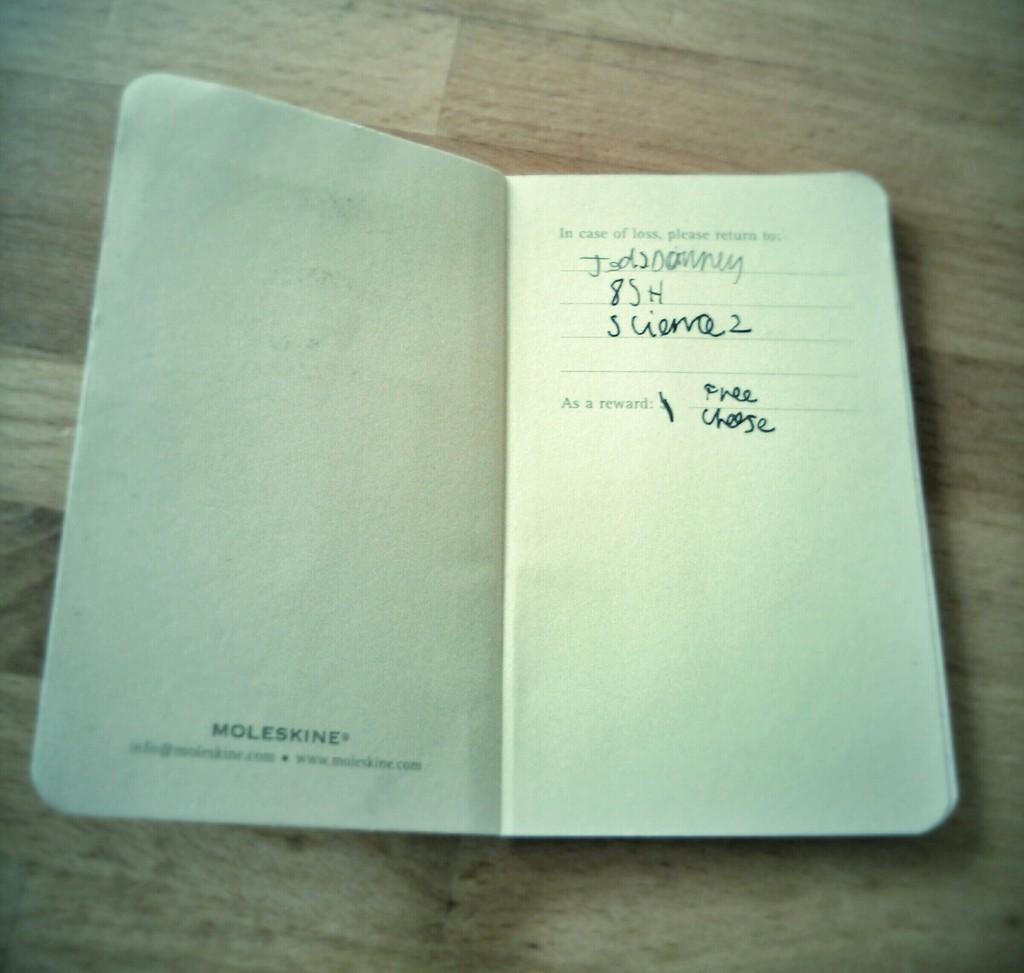<image>
Share a concise interpretation of the image provided. A white booklet that has information for In case of loss, please return to 